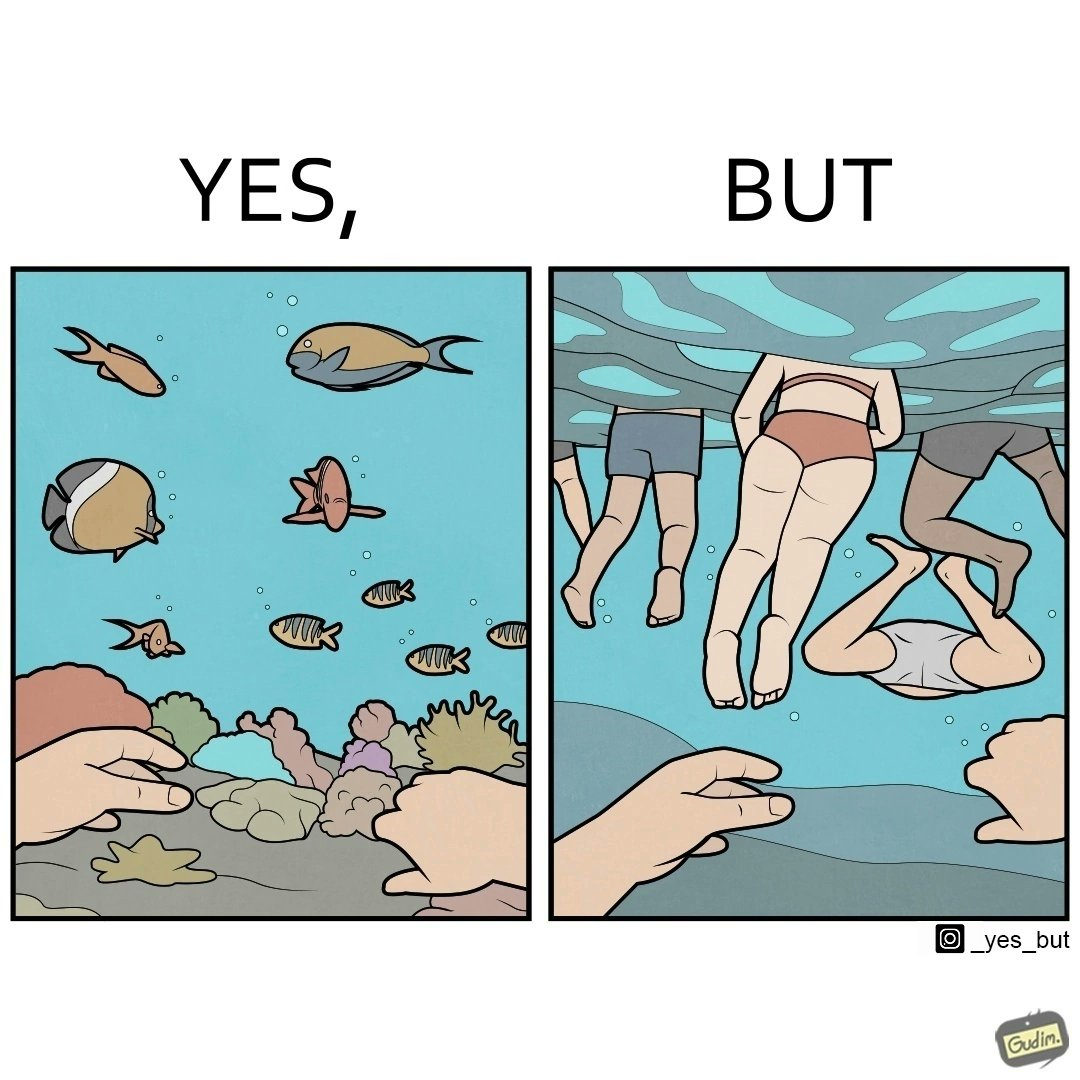Provide a description of this image. The image is ironic, because some people like to enjoy watching the biodiversity under water but they are not able to explore this due to excess crowd in such places where people like to play, swim etc. in water 